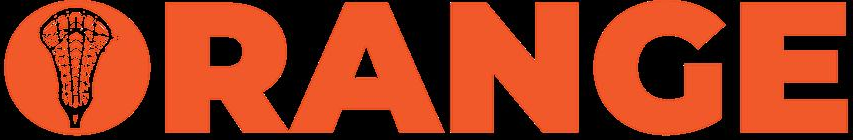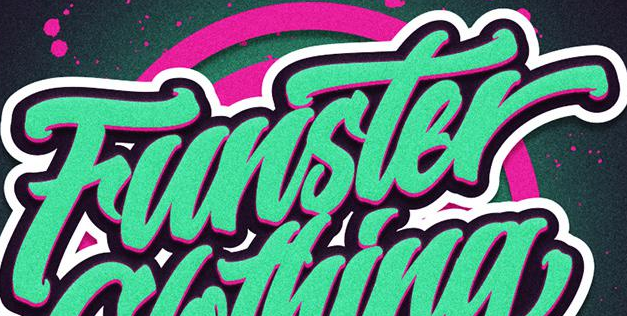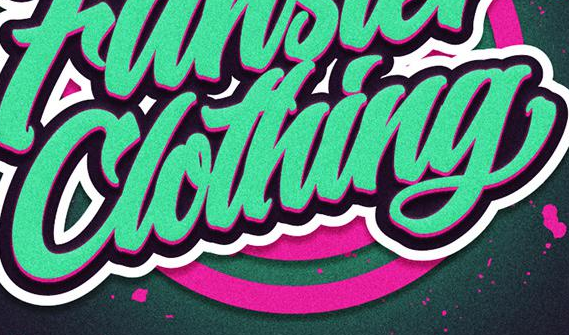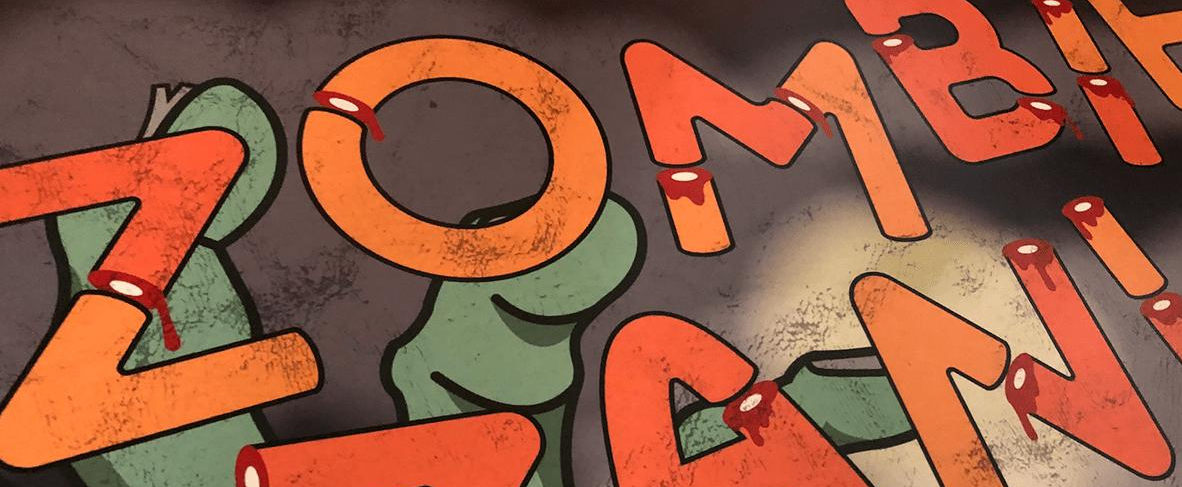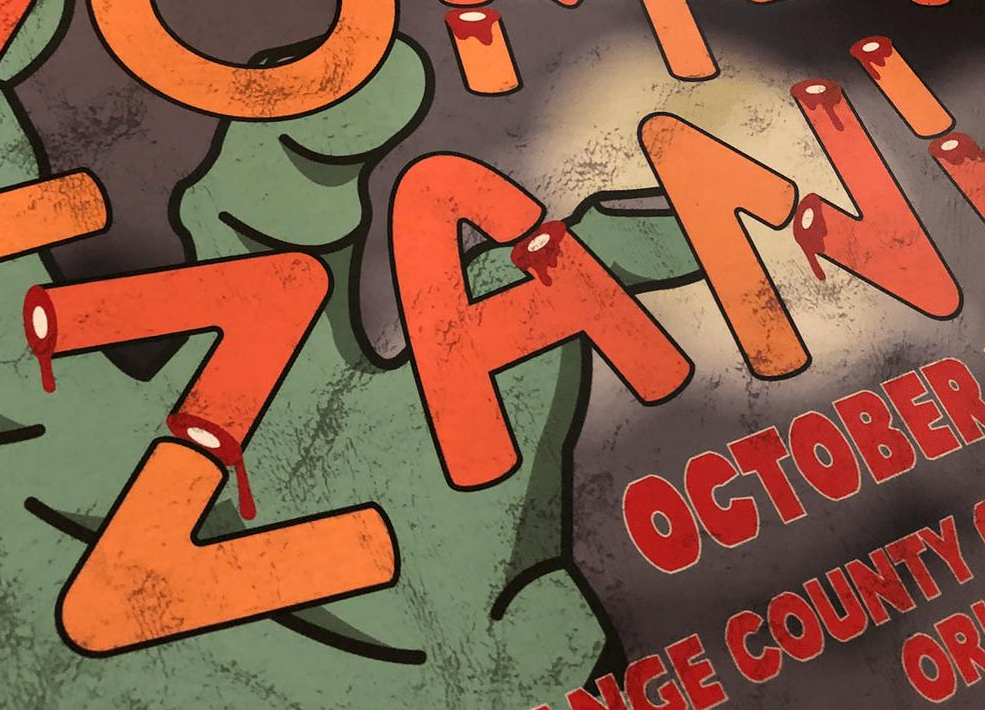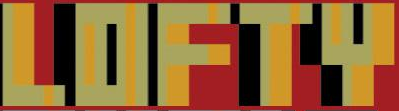Identify the words shown in these images in order, separated by a semicolon. ORANGE; Funster; Clothing; ZOMBI; ZANI; LOFTY 